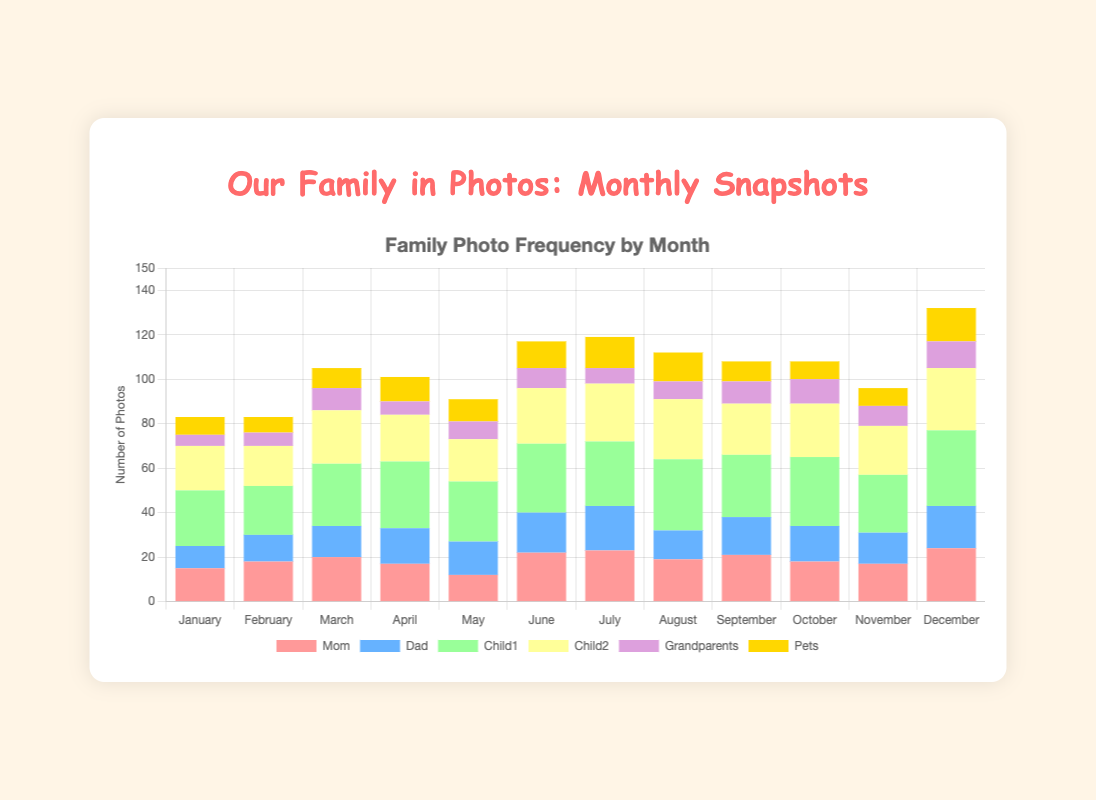Which month has the highest number of photos featuring 'Child1'? The month with the highest value for 'Child1' in the figure is December with 34 photos.
Answer: December Which family member appears most frequently in April? In April, 'Child1' has the highest number of photos, with 30 photos.
Answer: Child1 How many photos feature either 'Mom' or 'Dad' in February? In February, 'Mom' has 18 photos and 'Dad' has 12 photos. Adding them together gives 18 + 12 = 30 photos.
Answer: 30 Which family member has the least number of photos in July? In July, 'Grandparents' have the least number of photos, with a total of 7 photos.
Answer: Grandparents Compare the total number of photos of 'Pets' in the first half of the year (January to June) and the second half (July to December). Which half has more? The total for 'Pets' from January to June is 8 + 7 + 9 + 11 + 10 + 12 = 57. From July to December, it's 14 + 13 + 9 + 8 + 8 + 15 = 67. The second half has more photos.
Answer: Second half Which month has the lowest total number of photos featuring family members? In January, the total number of photos is 15 (Mom) + 10 (Dad) + 25 (Child1) + 20 (Child2) + 5 (Grandparents) + 8 (Pets) = 83, which is the lowest total across all months.
Answer: January What is the sum of the number of photos of 'Child2' and 'Grandparents' in October? In October, 'Child2' has 24 photos and 'Grandparents' has 11 photos. Adding them together gives 24 + 11 = 35.
Answer: 35 How does the number of photos of 'Mom' in March compare to those in May? In March, 'Mom' appears in 20 photos, while in May she appears in 12 photos. March has 8 more photos than May.
Answer: March has 8 more What is the average number of photos for 'Dad' across the entire year? Summing up the photos for 'Dad' across all months: 10 + 12 + 14 + 16 + 15 + 18 + 20 + 13 + 17 + 16 + 14 + 19 = 184 photos. There are 12 months, so the average is 184 / 12 = 15.3.
Answer: 15.3 In which month do 'Mom' and 'Pets' together have the highest number of photos? Adding the values of 'Mom' and 'Pets' for each month, December has the highest with 24 (Mom) + 15 (Pets) = 39 photos.
Answer: December 